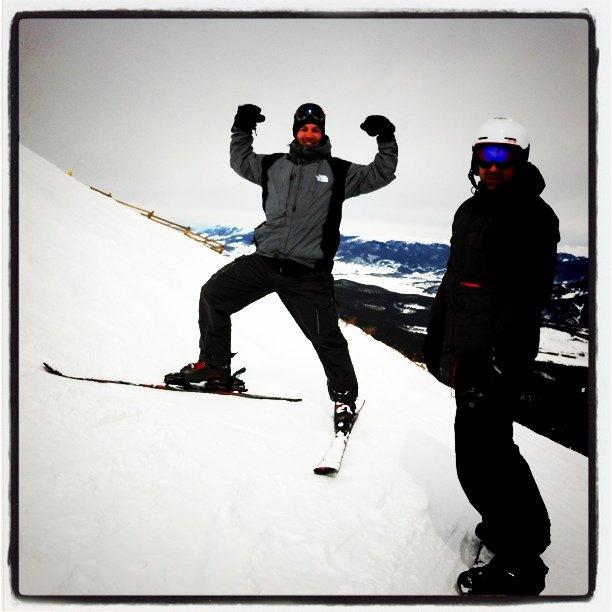How many people are there?
Quick response, please. 2. What activity are the people in this picture doing?
Answer briefly. Skiing. Are these people wearing hats?
Concise answer only. Yes. 